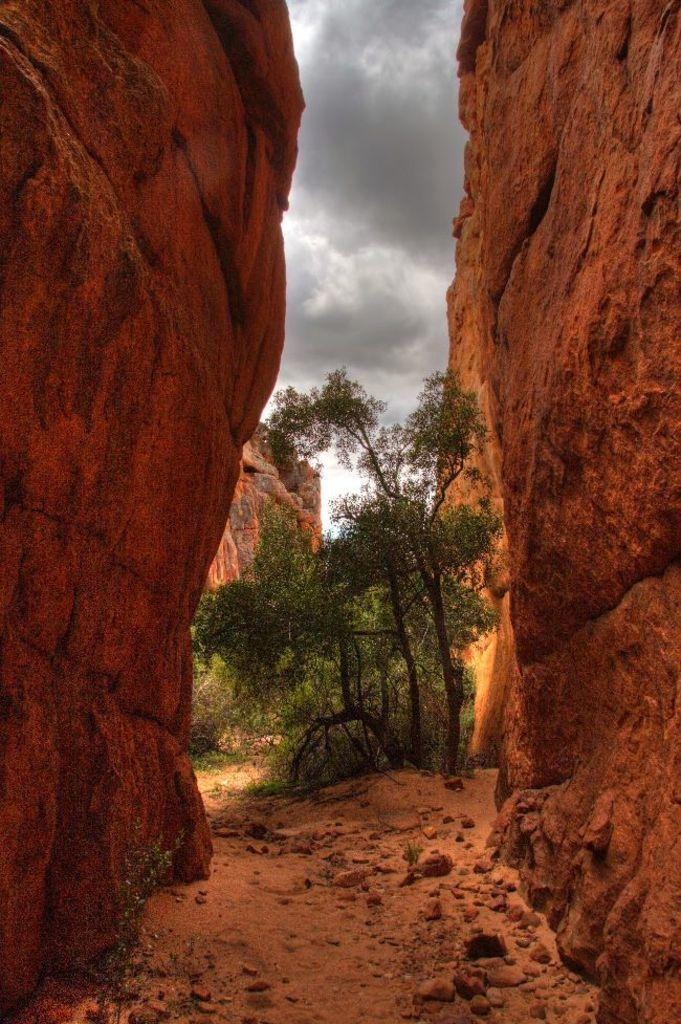What type of geological formations can be seen in the image? There are two rock hills in the image. What is located between the rock hills? There is a surface with stones and plants between the rock hills. Can you describe the background of the image? There are more rock hills visible behind the surface. What is visible in the sky in the image? The sky is visible in the image, and clouds are present. What type of horn can be seen on the rock hill in the image? There is no horn present on the rock hill in the image. What type of brass instrument is being played by the rock formation in the image? There is no brass instrument or rock formation playing an instrument in the image. 